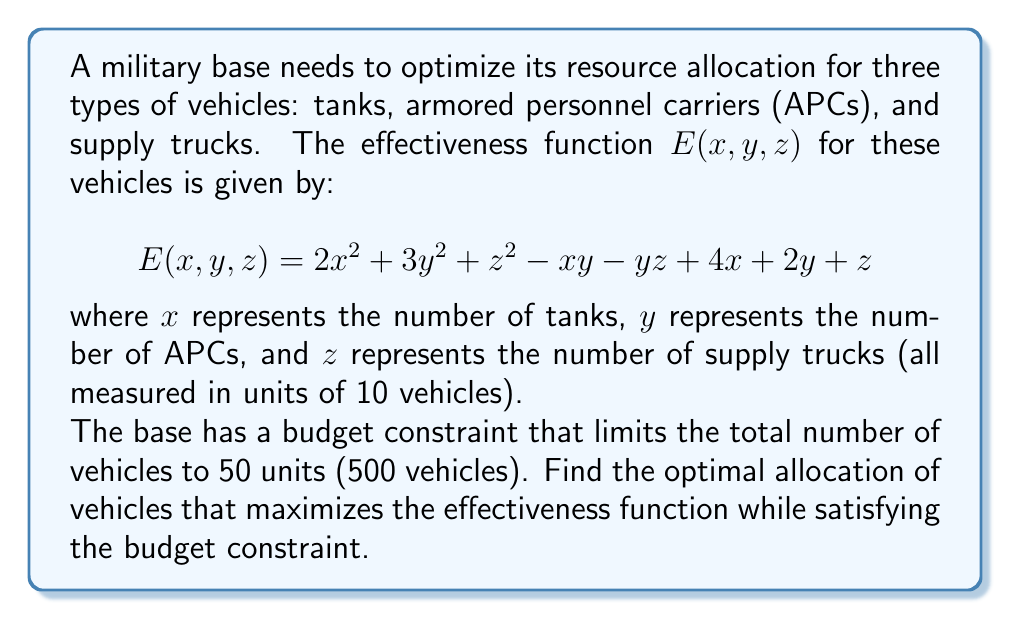Give your solution to this math problem. To solve this optimization problem with a constraint, we'll use the method of Lagrange multipliers.

1) First, let's define our constraint function:
   $$g(x, y, z) = x + y + z - 5 = 0$$ (since 50 units = 5 in our scale)

2) Now, we form the Lagrangian function:
   $$L(x, y, z, λ) = E(x, y, z) - λg(x, y, z)$$
   $$L(x, y, z, λ) = 2x^2 + 3y^2 + z^2 - xy - yz + 4x + 2y + z - λ(x + y + z - 5)$$

3) We find the partial derivatives and set them to zero:

   $$\frac{\partial L}{\partial x} = 4x - y + 4 - λ = 0$$
   $$\frac{\partial L}{\partial y} = 6y - x - z + 2 - λ = 0$$
   $$\frac{\partial L}{\partial z} = 2z - y + 1 - λ = 0$$
   $$\frac{\partial L}{\partial λ} = x + y + z - 5 = 0$$

4) From these equations:
   
   From (3): $z = \frac{y + λ - 1}{2}$
   
   Substitute this into (2):
   $$6y - x - \frac{y + λ - 1}{2} + 2 - λ = 0$$
   $$12y - 2x - y - λ + 1 + 4 - 2λ = 0$$
   $$11y - 2x - 3λ + 5 = 0$$

   From (1): $x = \frac{y + λ - 4}{4}$
   
   Substitute this into the equation above:
   $$11y - 2(\frac{y + λ - 4}{4}) - 3λ + 5 = 0$$
   $$44y - 2y - 2λ + 8 - 12λ + 20 = 0$$
   $$42y - 14λ + 28 = 0$$
   $$y = \frac{14λ - 28}{42} = \frac{λ - 2}{3}$$

5) Now we have:
   $$x = \frac{y + λ - 4}{4} = \frac{(\frac{λ - 2}{3}) + λ - 4}{4} = \frac{5λ - 14}{12}$$
   $$y = \frac{λ - 2}{3}$$
   $$z = \frac{y + λ - 1}{2} = \frac{(\frac{λ - 2}{3}) + λ - 1}{2} = \frac{5λ - 5}{6}$$

6) Substitute these into the constraint equation:
   $$\frac{5λ - 14}{12} + \frac{λ - 2}{3} + \frac{5λ - 5}{6} - 5 = 0$$
   
   Solving this equation gives us $λ = 6$.

7) Substituting $λ = 6$ back:
   $$x = \frac{5(6) - 14}{12} = 2$$
   $$y = \frac{6 - 2}{3} = \frac{4}{3}$$
   $$z = \frac{5(6) - 5}{6} = \frac{25}{6}$$

8) Converting back to number of vehicles (multiply by 10):
   Tanks (x): 20
   APCs (y): 13.33 ≈ 13
   Supply trucks (z): 41.67 ≈ 42
Answer: The optimal allocation is approximately 20 tanks, 13 APCs, and 42 supply trucks. 